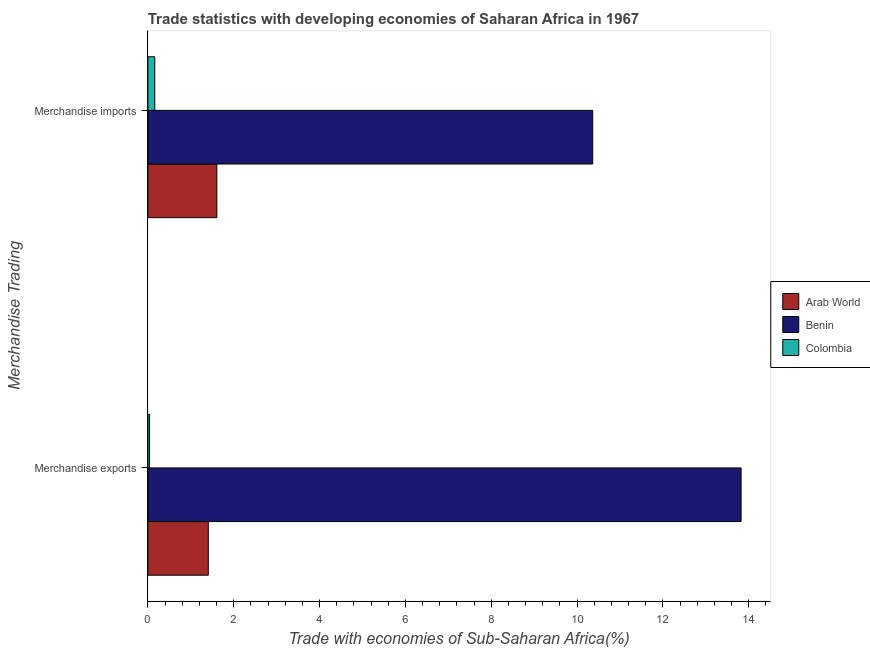What is the merchandise imports in Arab World?
Your answer should be very brief. 1.61. Across all countries, what is the maximum merchandise exports?
Offer a terse response. 13.82. Across all countries, what is the minimum merchandise imports?
Make the answer very short. 0.16. In which country was the merchandise exports maximum?
Offer a terse response. Benin. In which country was the merchandise exports minimum?
Offer a very short reply. Colombia. What is the total merchandise exports in the graph?
Provide a short and direct response. 15.27. What is the difference between the merchandise exports in Benin and that in Colombia?
Provide a short and direct response. 13.78. What is the difference between the merchandise imports in Benin and the merchandise exports in Arab World?
Provide a succinct answer. 8.96. What is the average merchandise exports per country?
Offer a very short reply. 5.09. What is the difference between the merchandise exports and merchandise imports in Colombia?
Make the answer very short. -0.12. In how many countries, is the merchandise imports greater than 8.4 %?
Make the answer very short. 1. What is the ratio of the merchandise exports in Arab World to that in Benin?
Your response must be concise. 0.1. Is the merchandise exports in Arab World less than that in Colombia?
Your response must be concise. No. What does the 3rd bar from the top in Merchandise imports represents?
Your answer should be very brief. Arab World. How many bars are there?
Your answer should be compact. 6. Are all the bars in the graph horizontal?
Give a very brief answer. Yes. Are the values on the major ticks of X-axis written in scientific E-notation?
Make the answer very short. No. Does the graph contain any zero values?
Offer a terse response. No. What is the title of the graph?
Provide a short and direct response. Trade statistics with developing economies of Saharan Africa in 1967. What is the label or title of the X-axis?
Offer a very short reply. Trade with economies of Sub-Saharan Africa(%). What is the label or title of the Y-axis?
Your answer should be compact. Merchandise Trading. What is the Trade with economies of Sub-Saharan Africa(%) of Arab World in Merchandise exports?
Give a very brief answer. 1.41. What is the Trade with economies of Sub-Saharan Africa(%) in Benin in Merchandise exports?
Keep it short and to the point. 13.82. What is the Trade with economies of Sub-Saharan Africa(%) of Colombia in Merchandise exports?
Your answer should be compact. 0.04. What is the Trade with economies of Sub-Saharan Africa(%) of Arab World in Merchandise imports?
Keep it short and to the point. 1.61. What is the Trade with economies of Sub-Saharan Africa(%) of Benin in Merchandise imports?
Your answer should be compact. 10.37. What is the Trade with economies of Sub-Saharan Africa(%) of Colombia in Merchandise imports?
Provide a short and direct response. 0.16. Across all Merchandise Trading, what is the maximum Trade with economies of Sub-Saharan Africa(%) of Arab World?
Give a very brief answer. 1.61. Across all Merchandise Trading, what is the maximum Trade with economies of Sub-Saharan Africa(%) of Benin?
Your answer should be compact. 13.82. Across all Merchandise Trading, what is the maximum Trade with economies of Sub-Saharan Africa(%) in Colombia?
Your response must be concise. 0.16. Across all Merchandise Trading, what is the minimum Trade with economies of Sub-Saharan Africa(%) in Arab World?
Offer a very short reply. 1.41. Across all Merchandise Trading, what is the minimum Trade with economies of Sub-Saharan Africa(%) of Benin?
Your answer should be compact. 10.37. Across all Merchandise Trading, what is the minimum Trade with economies of Sub-Saharan Africa(%) of Colombia?
Your response must be concise. 0.04. What is the total Trade with economies of Sub-Saharan Africa(%) of Arab World in the graph?
Provide a short and direct response. 3.02. What is the total Trade with economies of Sub-Saharan Africa(%) in Benin in the graph?
Provide a short and direct response. 24.19. What is the total Trade with economies of Sub-Saharan Africa(%) of Colombia in the graph?
Offer a terse response. 0.2. What is the difference between the Trade with economies of Sub-Saharan Africa(%) in Arab World in Merchandise exports and that in Merchandise imports?
Give a very brief answer. -0.2. What is the difference between the Trade with economies of Sub-Saharan Africa(%) in Benin in Merchandise exports and that in Merchandise imports?
Provide a succinct answer. 3.46. What is the difference between the Trade with economies of Sub-Saharan Africa(%) of Colombia in Merchandise exports and that in Merchandise imports?
Offer a terse response. -0.12. What is the difference between the Trade with economies of Sub-Saharan Africa(%) of Arab World in Merchandise exports and the Trade with economies of Sub-Saharan Africa(%) of Benin in Merchandise imports?
Your response must be concise. -8.96. What is the difference between the Trade with economies of Sub-Saharan Africa(%) in Arab World in Merchandise exports and the Trade with economies of Sub-Saharan Africa(%) in Colombia in Merchandise imports?
Provide a succinct answer. 1.25. What is the difference between the Trade with economies of Sub-Saharan Africa(%) in Benin in Merchandise exports and the Trade with economies of Sub-Saharan Africa(%) in Colombia in Merchandise imports?
Ensure brevity in your answer.  13.66. What is the average Trade with economies of Sub-Saharan Africa(%) of Arab World per Merchandise Trading?
Your response must be concise. 1.51. What is the average Trade with economies of Sub-Saharan Africa(%) of Benin per Merchandise Trading?
Give a very brief answer. 12.09. What is the average Trade with economies of Sub-Saharan Africa(%) in Colombia per Merchandise Trading?
Provide a short and direct response. 0.1. What is the difference between the Trade with economies of Sub-Saharan Africa(%) of Arab World and Trade with economies of Sub-Saharan Africa(%) of Benin in Merchandise exports?
Offer a terse response. -12.41. What is the difference between the Trade with economies of Sub-Saharan Africa(%) in Arab World and Trade with economies of Sub-Saharan Africa(%) in Colombia in Merchandise exports?
Keep it short and to the point. 1.37. What is the difference between the Trade with economies of Sub-Saharan Africa(%) in Benin and Trade with economies of Sub-Saharan Africa(%) in Colombia in Merchandise exports?
Offer a terse response. 13.78. What is the difference between the Trade with economies of Sub-Saharan Africa(%) in Arab World and Trade with economies of Sub-Saharan Africa(%) in Benin in Merchandise imports?
Your answer should be compact. -8.76. What is the difference between the Trade with economies of Sub-Saharan Africa(%) of Arab World and Trade with economies of Sub-Saharan Africa(%) of Colombia in Merchandise imports?
Make the answer very short. 1.45. What is the difference between the Trade with economies of Sub-Saharan Africa(%) in Benin and Trade with economies of Sub-Saharan Africa(%) in Colombia in Merchandise imports?
Ensure brevity in your answer.  10.2. What is the ratio of the Trade with economies of Sub-Saharan Africa(%) in Arab World in Merchandise exports to that in Merchandise imports?
Make the answer very short. 0.88. What is the ratio of the Trade with economies of Sub-Saharan Africa(%) in Benin in Merchandise exports to that in Merchandise imports?
Offer a very short reply. 1.33. What is the ratio of the Trade with economies of Sub-Saharan Africa(%) of Colombia in Merchandise exports to that in Merchandise imports?
Offer a very short reply. 0.24. What is the difference between the highest and the second highest Trade with economies of Sub-Saharan Africa(%) in Arab World?
Give a very brief answer. 0.2. What is the difference between the highest and the second highest Trade with economies of Sub-Saharan Africa(%) in Benin?
Your answer should be compact. 3.46. What is the difference between the highest and the second highest Trade with economies of Sub-Saharan Africa(%) in Colombia?
Keep it short and to the point. 0.12. What is the difference between the highest and the lowest Trade with economies of Sub-Saharan Africa(%) of Arab World?
Ensure brevity in your answer.  0.2. What is the difference between the highest and the lowest Trade with economies of Sub-Saharan Africa(%) in Benin?
Your answer should be compact. 3.46. What is the difference between the highest and the lowest Trade with economies of Sub-Saharan Africa(%) in Colombia?
Ensure brevity in your answer.  0.12. 